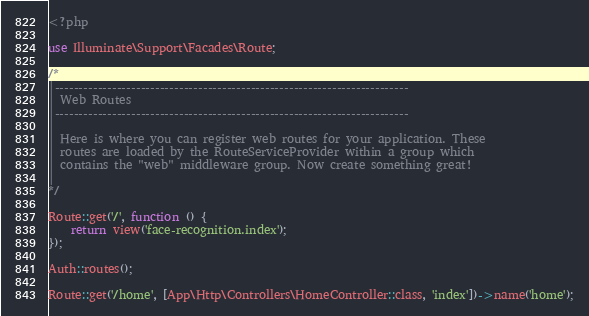Convert code to text. <code><loc_0><loc_0><loc_500><loc_500><_PHP_><?php

use Illuminate\Support\Facades\Route;

/*
|--------------------------------------------------------------------------
| Web Routes
|--------------------------------------------------------------------------
|
| Here is where you can register web routes for your application. These
| routes are loaded by the RouteServiceProvider within a group which
| contains the "web" middleware group. Now create something great!
|
*/

Route::get('/', function () {
    return view('face-recognition.index');
});

Auth::routes();

Route::get('/home', [App\Http\Controllers\HomeController::class, 'index'])->name('home');
</code> 